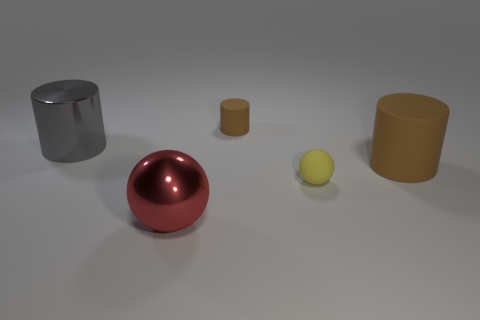Add 3 big gray matte blocks. How many objects exist? 8 Subtract all balls. How many objects are left? 3 Add 1 tiny cylinders. How many tiny cylinders are left? 2 Add 3 tiny cyan blocks. How many tiny cyan blocks exist? 3 Subtract 0 purple cylinders. How many objects are left? 5 Subtract all tiny yellow rubber balls. Subtract all big gray metal things. How many objects are left? 3 